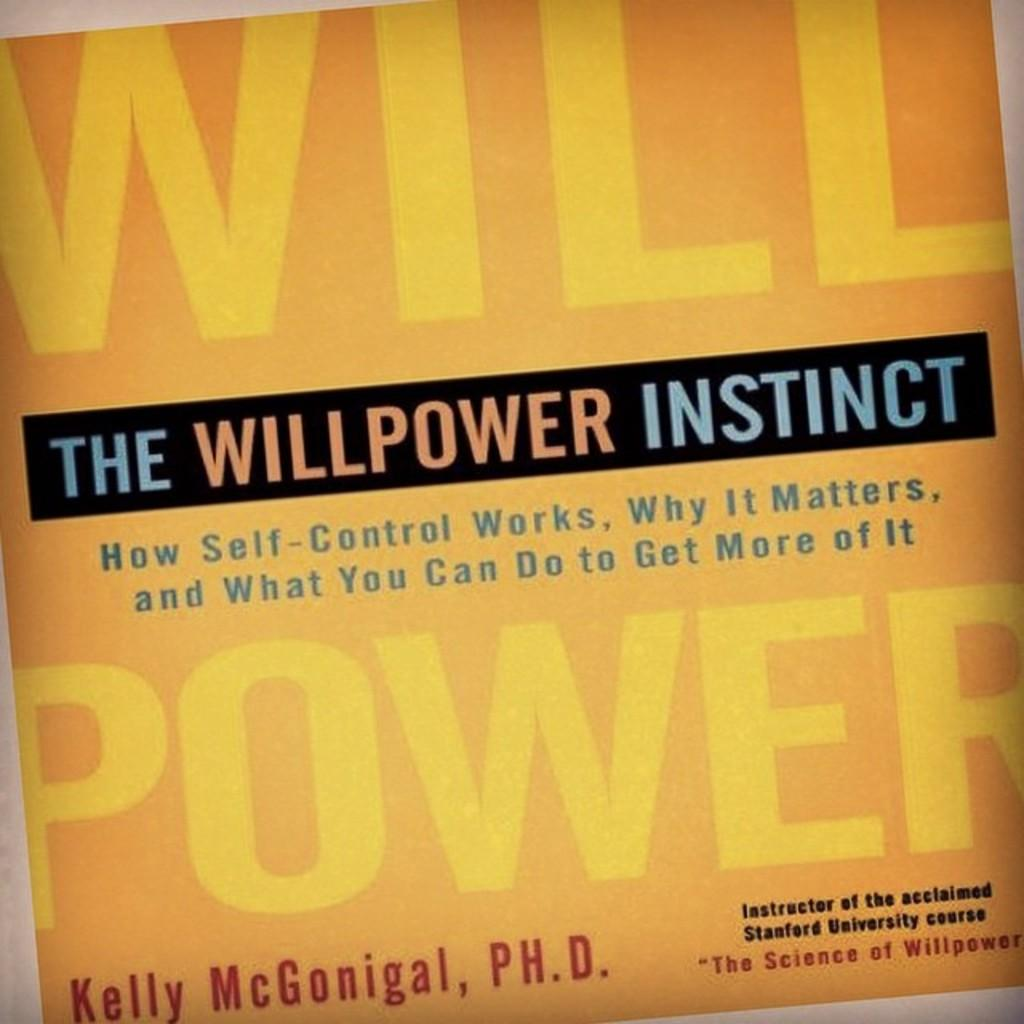Provide a one-sentence caption for the provided image. The yellow cover of the book "The Willpower Instinct". 